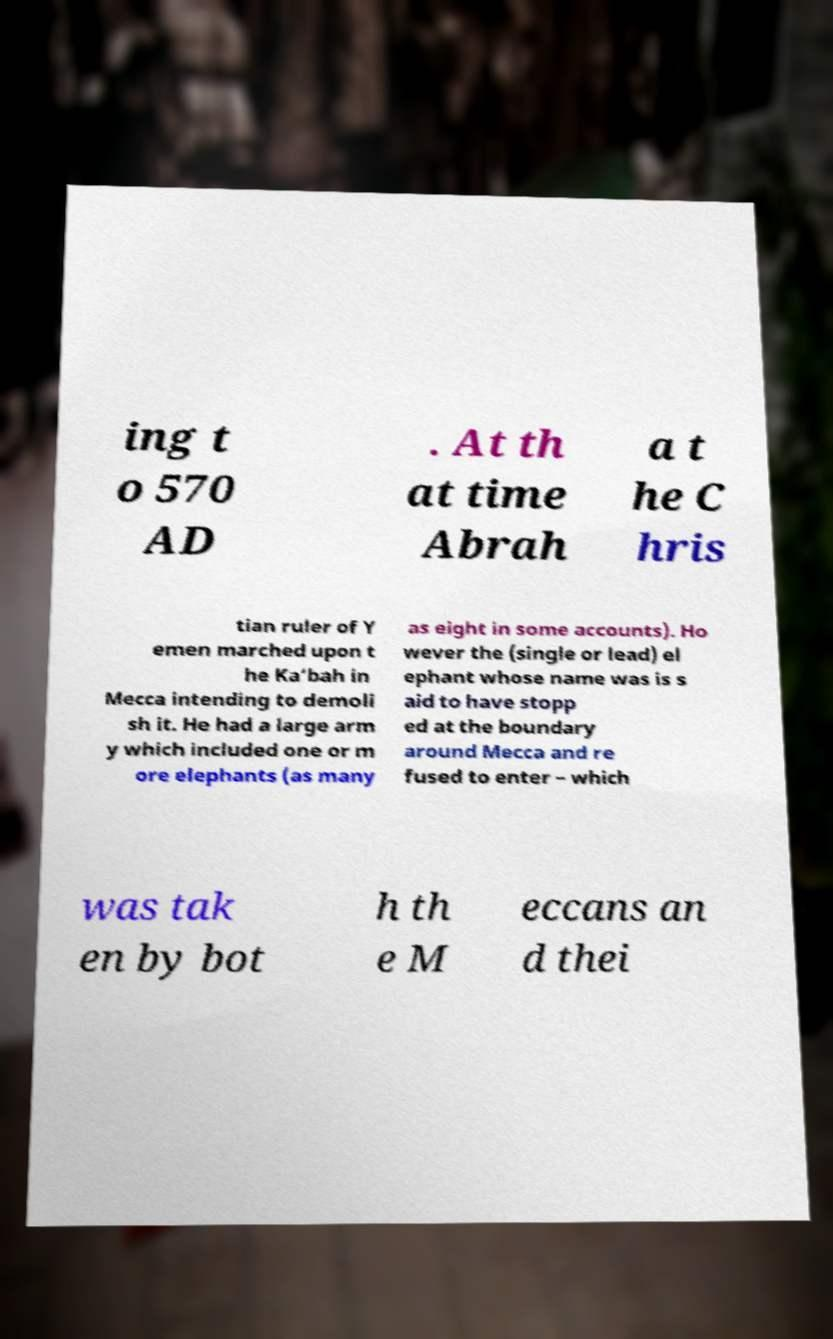Could you extract and type out the text from this image? ing t o 570 AD . At th at time Abrah a t he C hris tian ruler of Y emen marched upon t he Ka‘bah in Mecca intending to demoli sh it. He had a large arm y which included one or m ore elephants (as many as eight in some accounts). Ho wever the (single or lead) el ephant whose name was is s aid to have stopp ed at the boundary around Mecca and re fused to enter – which was tak en by bot h th e M eccans an d thei 